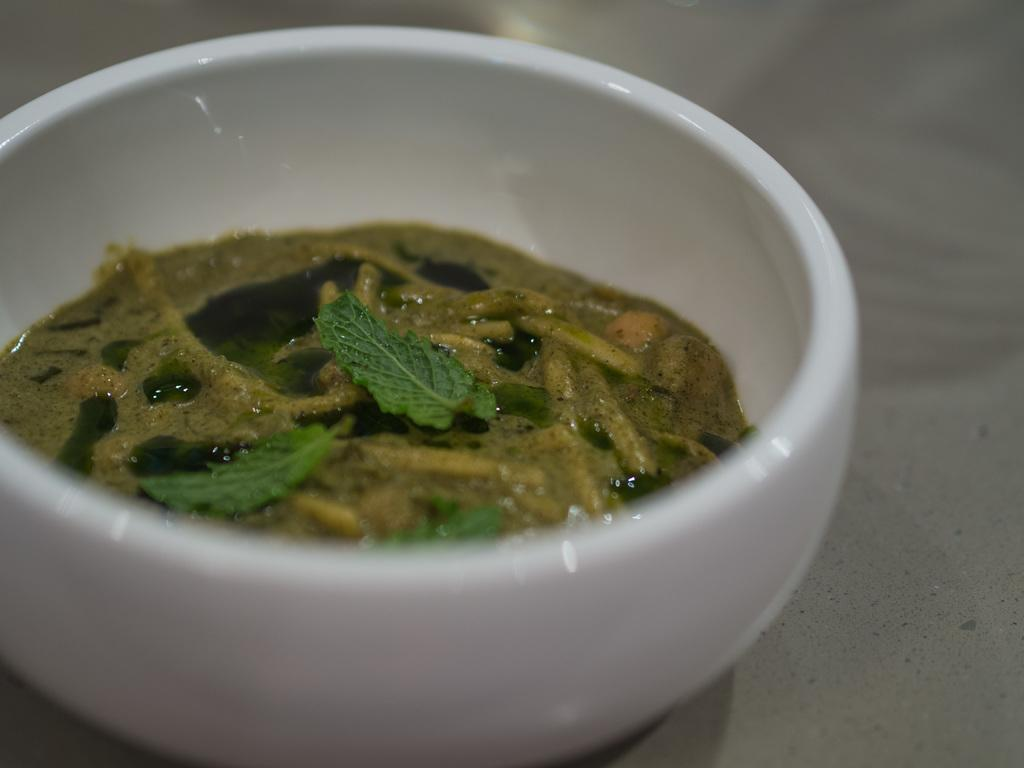What is in the bowl that is visible in the image? There is soup in a bowl in the image. What piece of furniture is present at the bottom of the image? There is a table at the bottom of the image. What type of cave can be seen in the background of the image? There is no cave present in the image. What is the temperature of the soup in the image? The temperature of the soup cannot be determined from the image alone. 